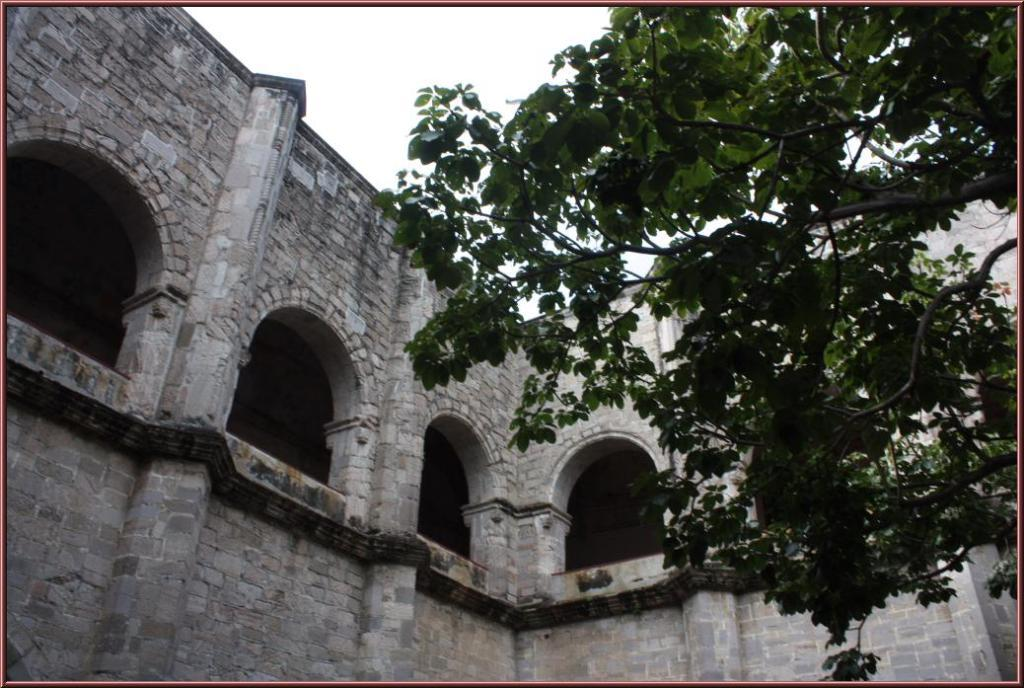What is located at the front of the image? There is a tree in the front of the image. What can be seen in the background of the image? There is a building in the background of the image. How would you describe the sky in the image? The sky is cloudy in the image. What holiday is being celebrated in the image? There is no indication of a holiday being celebrated in the image. Can you tell me who won the competition depicted in the image? There is no competition depicted in the image. 